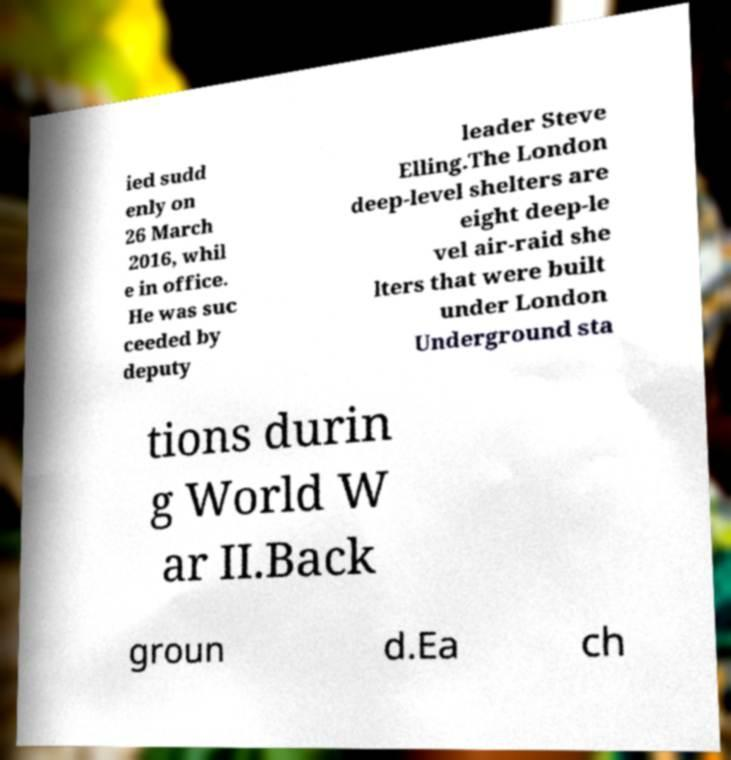Please identify and transcribe the text found in this image. ied sudd enly on 26 March 2016, whil e in office. He was suc ceeded by deputy leader Steve Elling.The London deep-level shelters are eight deep-le vel air-raid she lters that were built under London Underground sta tions durin g World W ar II.Back groun d.Ea ch 